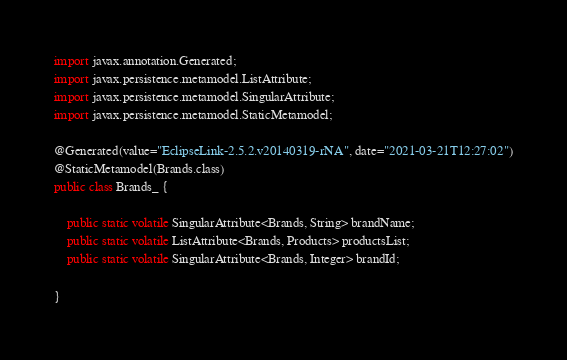Convert code to text. <code><loc_0><loc_0><loc_500><loc_500><_Java_>import javax.annotation.Generated;
import javax.persistence.metamodel.ListAttribute;
import javax.persistence.metamodel.SingularAttribute;
import javax.persistence.metamodel.StaticMetamodel;

@Generated(value="EclipseLink-2.5.2.v20140319-rNA", date="2021-03-21T12:27:02")
@StaticMetamodel(Brands.class)
public class Brands_ { 

    public static volatile SingularAttribute<Brands, String> brandName;
    public static volatile ListAttribute<Brands, Products> productsList;
    public static volatile SingularAttribute<Brands, Integer> brandId;

}</code> 